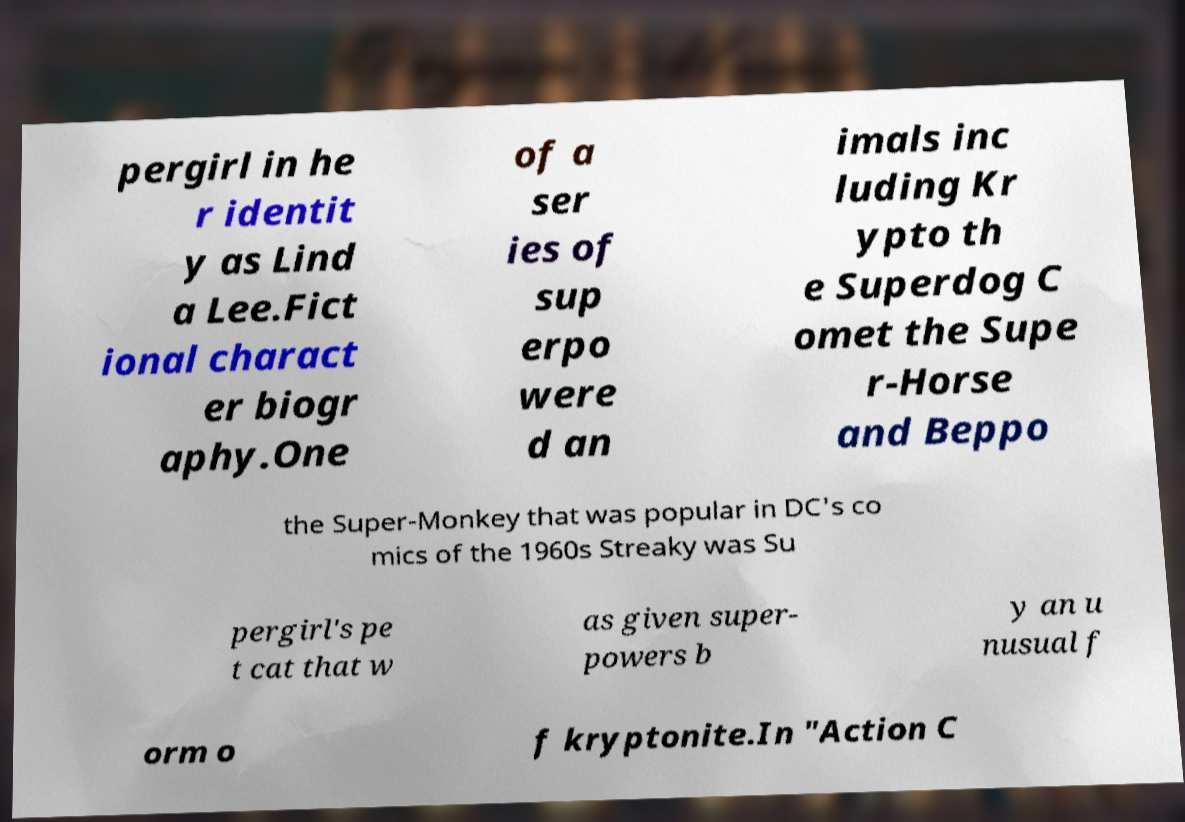Could you assist in decoding the text presented in this image and type it out clearly? pergirl in he r identit y as Lind a Lee.Fict ional charact er biogr aphy.One of a ser ies of sup erpo were d an imals inc luding Kr ypto th e Superdog C omet the Supe r-Horse and Beppo the Super-Monkey that was popular in DC's co mics of the 1960s Streaky was Su pergirl's pe t cat that w as given super- powers b y an u nusual f orm o f kryptonite.In "Action C 